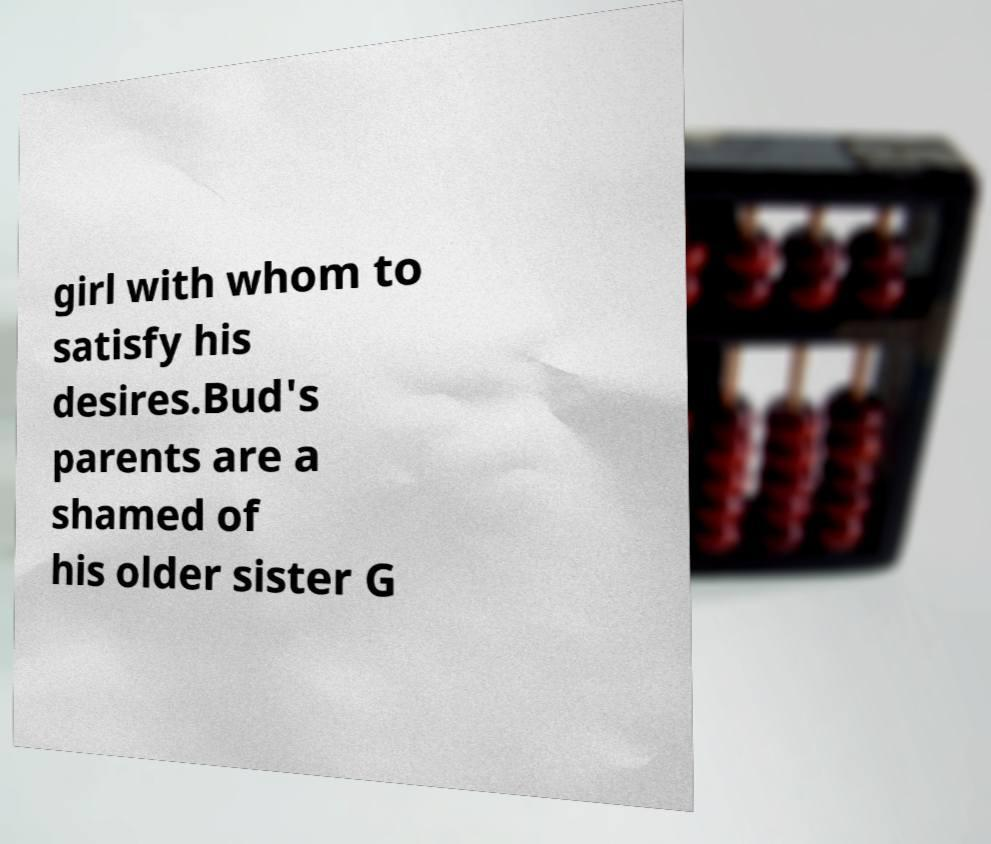Can you accurately transcribe the text from the provided image for me? girl with whom to satisfy his desires.Bud's parents are a shamed of his older sister G 